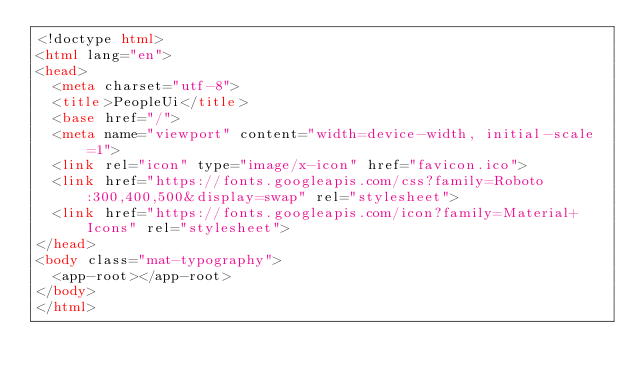Convert code to text. <code><loc_0><loc_0><loc_500><loc_500><_HTML_><!doctype html>
<html lang="en">
<head>
  <meta charset="utf-8">
  <title>PeopleUi</title>
  <base href="/">
  <meta name="viewport" content="width=device-width, initial-scale=1">
  <link rel="icon" type="image/x-icon" href="favicon.ico">
  <link href="https://fonts.googleapis.com/css?family=Roboto:300,400,500&display=swap" rel="stylesheet">
  <link href="https://fonts.googleapis.com/icon?family=Material+Icons" rel="stylesheet">
</head>
<body class="mat-typography">
  <app-root></app-root>
</body>
</html>
</code> 